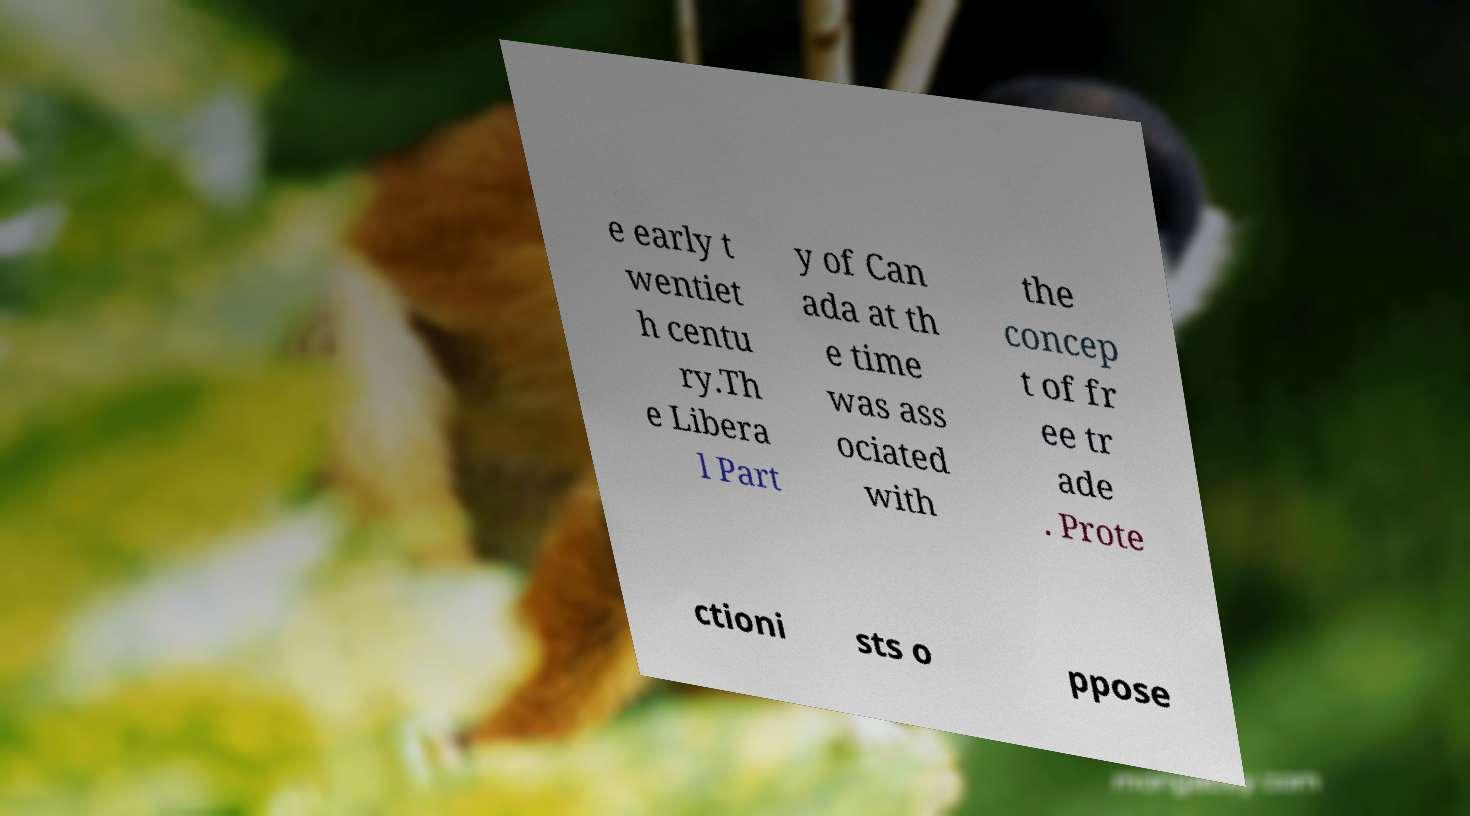Can you accurately transcribe the text from the provided image for me? e early t wentiet h centu ry.Th e Libera l Part y of Can ada at th e time was ass ociated with the concep t of fr ee tr ade . Prote ctioni sts o ppose 